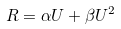<formula> <loc_0><loc_0><loc_500><loc_500>R = \alpha U + \beta U ^ { 2 }</formula> 